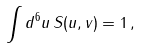Convert formula to latex. <formula><loc_0><loc_0><loc_500><loc_500>\int d ^ { 6 } u \, S ( u , v ) = 1 \, ,</formula> 